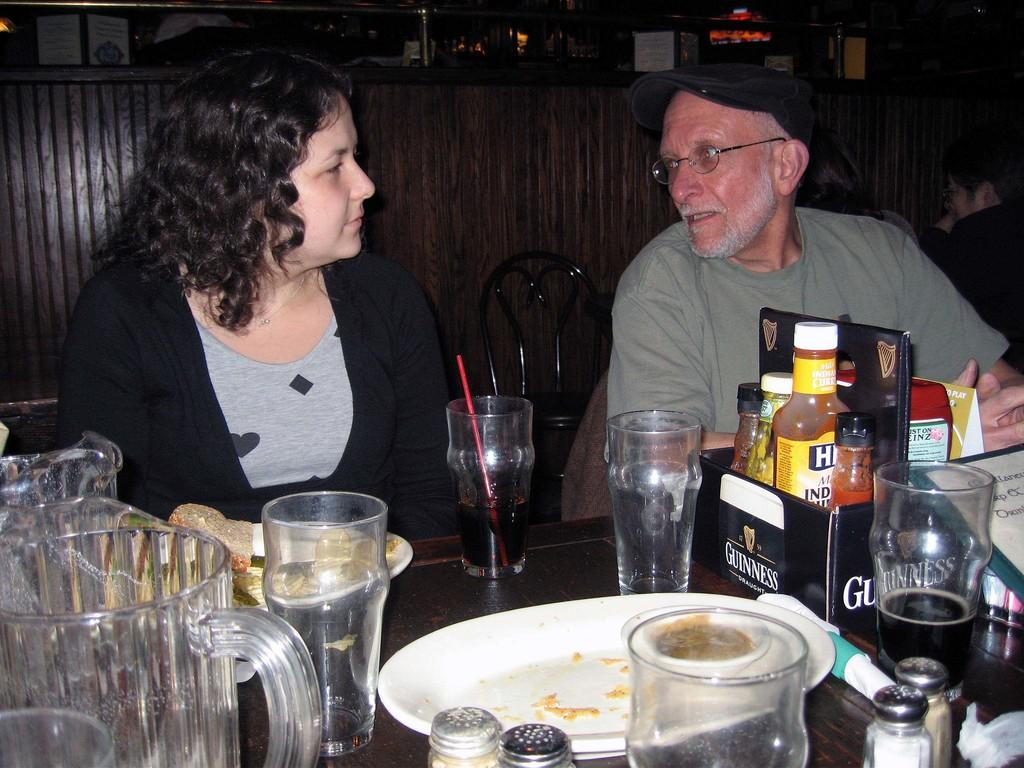What are the people in the image doing? The people in the image are sitting on chairs. What objects can be seen on the table in the image? There are glasses, jars, and plates on the table in the image. What type of car is parked in the image? There is no car present in the image. Can you see a zipper on any of the plates in the image? There are no zippers visible in the image, as the plates are not clothing items. 